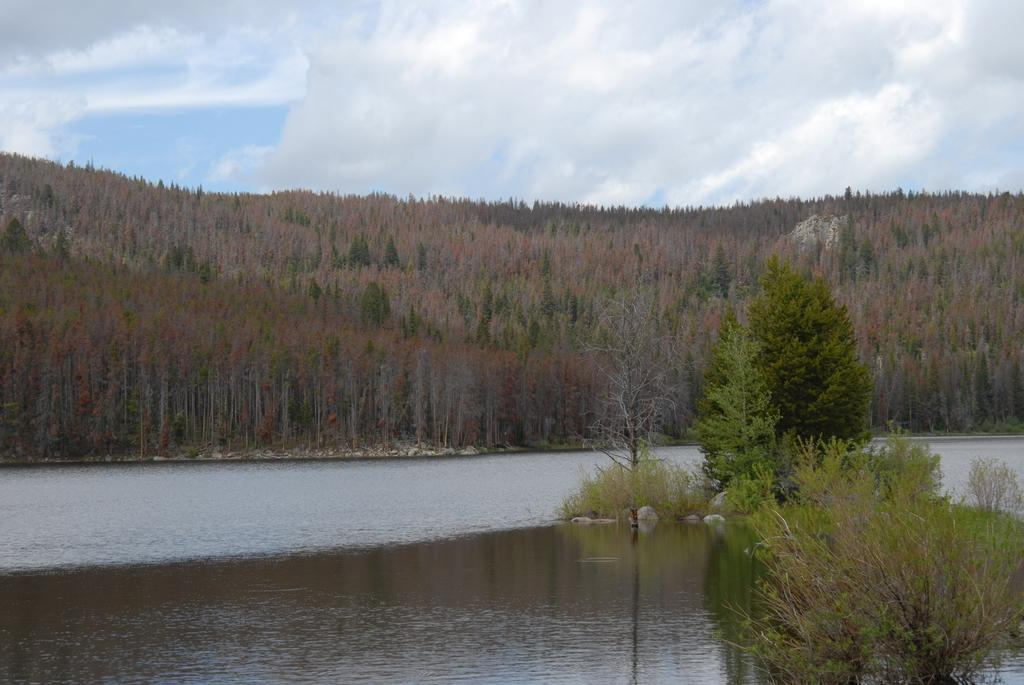What is present at the bottom of the image? There is water at the bottom of the image. What can be seen in the middle of the image? There are trees in the middle of the image. What is visible in the sky at the top of the image? There are clouds visible in the sky at the top of the image. What type of produce is being harvested in the image? There is no produce or harvesting activity present in the image. Can you see a guide leading a group of people in the image? There is no guide or group of people present in the image. 